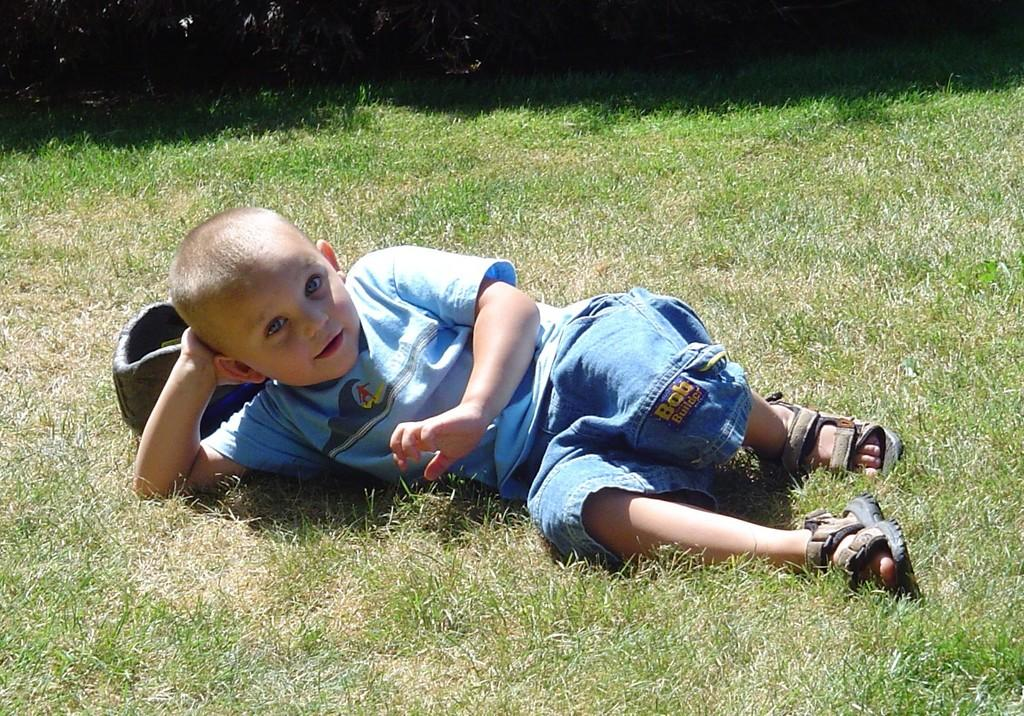Who is the main subject in the picture? There is a boy in the picture. What is the boy doing in the image? The boy is lying on the ground. What type of surface is the boy lying on? There is grass on the ground. What type of order is the boy following in the image? There is no order or instructions mentioned in the image, and the boy is simply lying on the grass. 